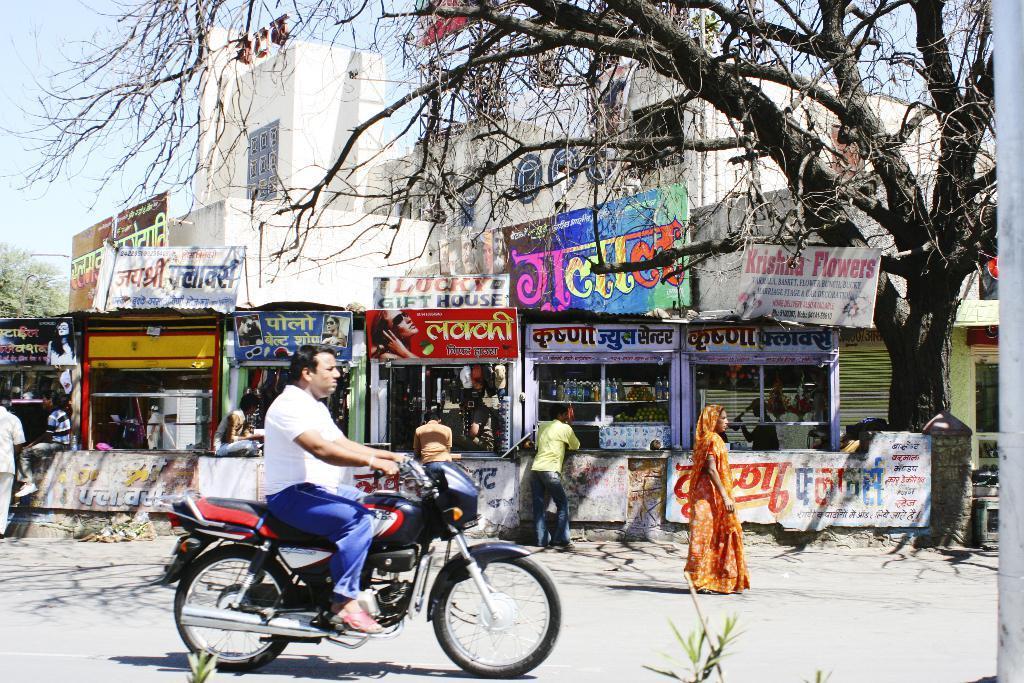Please provide a concise description of this image. In the image there is there a man sat on a bike, and on the backside there are many streets, the picture clicked on street and on the right side there is a tree. 